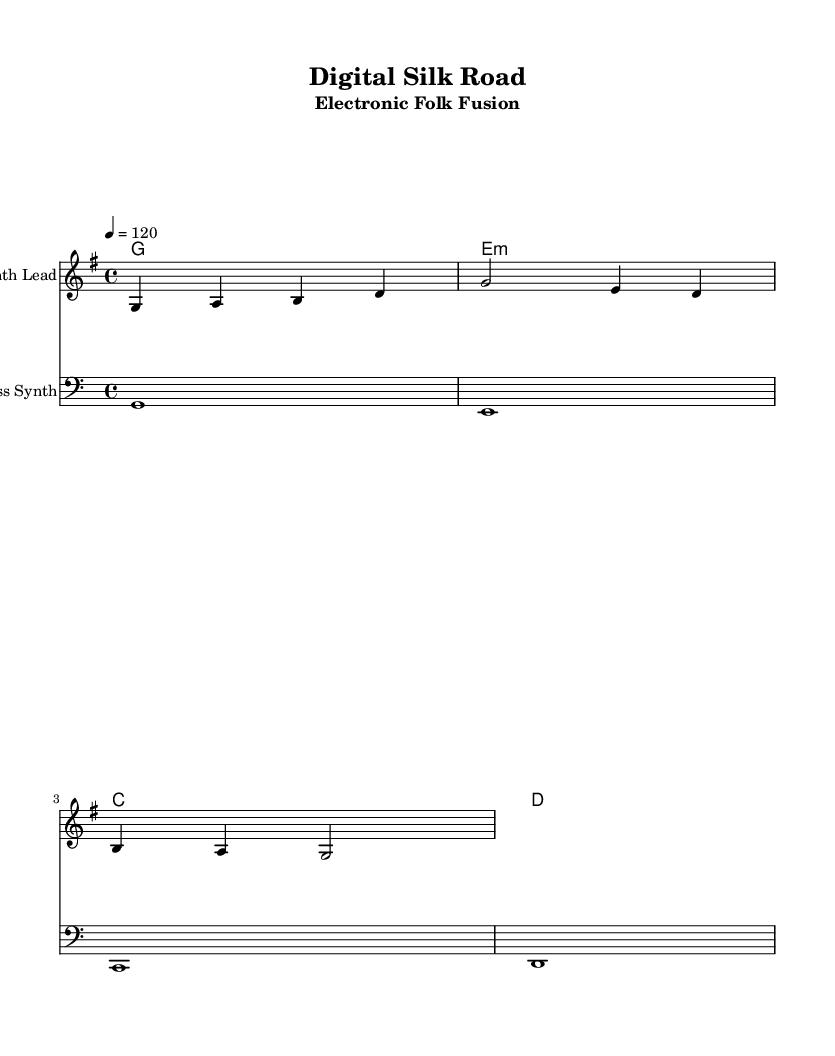What is the key signature of this music? The key signature is G major, which features one sharp (F#). This can be found at the beginning of the staff, right after the clef.
Answer: G major What is the time signature of this music? The time signature is 4/4, indicated at the beginning of the score on the staff. This means there are four beats per measure, and the quarter note gets one beat.
Answer: 4/4 What is the tempo marking of this piece? The tempo marking is quarter note equals 120 BPM, specified in the tempo line at the beginning of the score. This informs performers how fast the piece should be played.
Answer: 120 How many measures are in the melody part? There are three measures in the melody part, as seen by counting the vertical bar lines that divide the measures. Counting reveals that the melody is structured into three distinct measures.
Answer: 3 What type of instrument is represented by the "Synth Lead" staff? The "Synth Lead" staff indicates the sound is generated by a synthesizer, which is a common instrument in electronic music for producing various timbres and effects. This is identified by the annotated instrument name above the staff.
Answer: Synthesizer How many chords are there in the harmonies section? There are four chords listed in the harmonies section, which can be counted directly from the chord symbols indicated throughout the measure. Each symbol represents a chord played in that measure.
Answer: 4 What is the bass clef for in this score? The bass clef is used to indicate lower pitches in the bass line, specifically for instruments like bass guitars or synthesizers. The bass line section starts with a bass clef symbol, clarifying that these notes are intended for lower ranges.
Answer: Bass line 